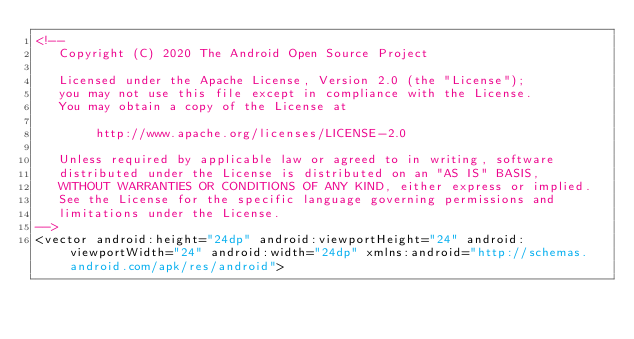Convert code to text. <code><loc_0><loc_0><loc_500><loc_500><_XML_><!--
   Copyright (C) 2020 The Android Open Source Project

   Licensed under the Apache License, Version 2.0 (the "License");
   you may not use this file except in compliance with the License.
   You may obtain a copy of the License at

        http://www.apache.org/licenses/LICENSE-2.0

   Unless required by applicable law or agreed to in writing, software
   distributed under the License is distributed on an "AS IS" BASIS,
   WITHOUT WARRANTIES OR CONDITIONS OF ANY KIND, either express or implied.
   See the License for the specific language governing permissions and
   limitations under the License.
-->
<vector android:height="24dp" android:viewportHeight="24" android:viewportWidth="24" android:width="24dp" xmlns:android="http://schemas.android.com/apk/res/android"></code> 